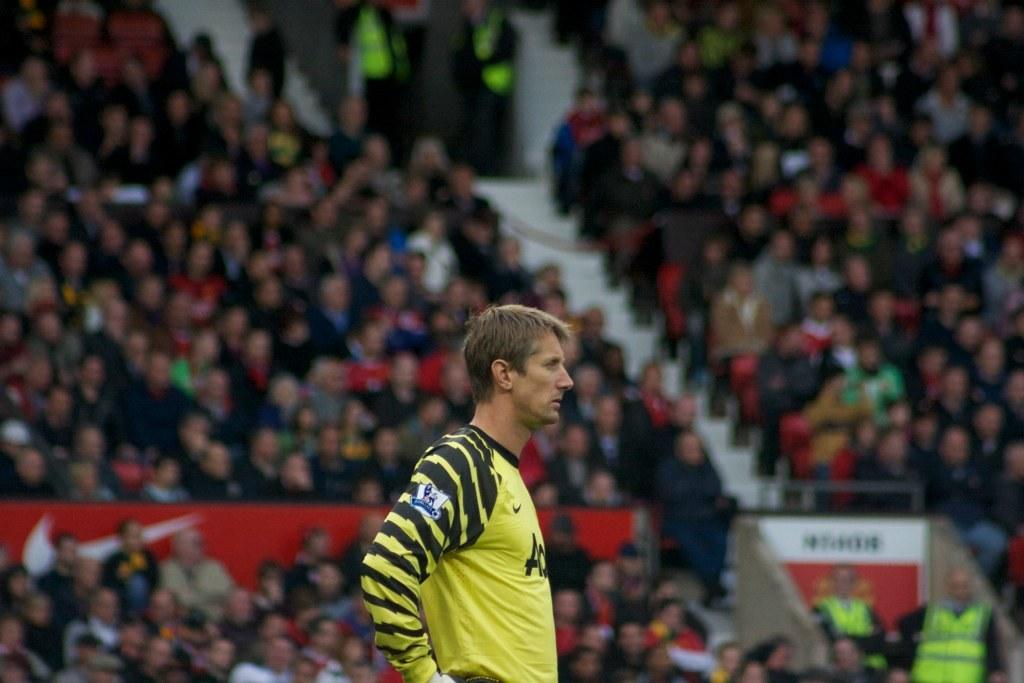What is the main subject of the image? There is a person standing in the center of the image. What can be seen in the background of the image? There is a fence visible in the image. Are there any architectural features in the image? Yes, there are stairs in the image. What are the other people in the image doing? There is a group of people sitting on chairs in the image. What time of day is it in the image, based on the hour? The provided facts do not mention the time of day or any specific hour, so it cannot be determined from the image. 